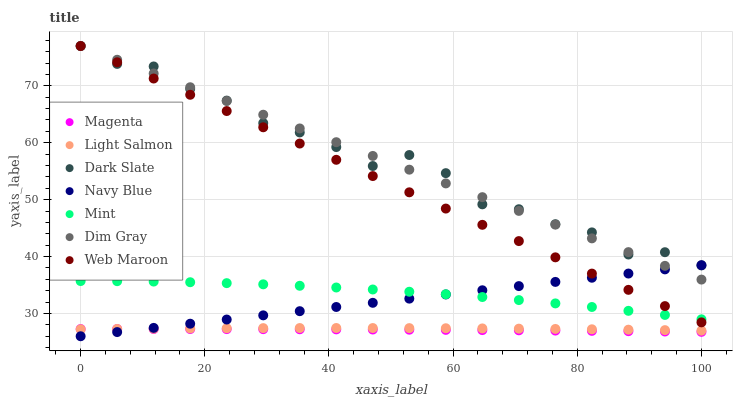Does Magenta have the minimum area under the curve?
Answer yes or no. Yes. Does Dark Slate have the maximum area under the curve?
Answer yes or no. Yes. Does Dim Gray have the minimum area under the curve?
Answer yes or no. No. Does Dim Gray have the maximum area under the curve?
Answer yes or no. No. Is Dim Gray the smoothest?
Answer yes or no. Yes. Is Dark Slate the roughest?
Answer yes or no. Yes. Is Navy Blue the smoothest?
Answer yes or no. No. Is Navy Blue the roughest?
Answer yes or no. No. Does Navy Blue have the lowest value?
Answer yes or no. Yes. Does Dim Gray have the lowest value?
Answer yes or no. No. Does Dark Slate have the highest value?
Answer yes or no. Yes. Does Navy Blue have the highest value?
Answer yes or no. No. Is Light Salmon less than Dark Slate?
Answer yes or no. Yes. Is Dim Gray greater than Mint?
Answer yes or no. Yes. Does Magenta intersect Light Salmon?
Answer yes or no. Yes. Is Magenta less than Light Salmon?
Answer yes or no. No. Is Magenta greater than Light Salmon?
Answer yes or no. No. Does Light Salmon intersect Dark Slate?
Answer yes or no. No. 